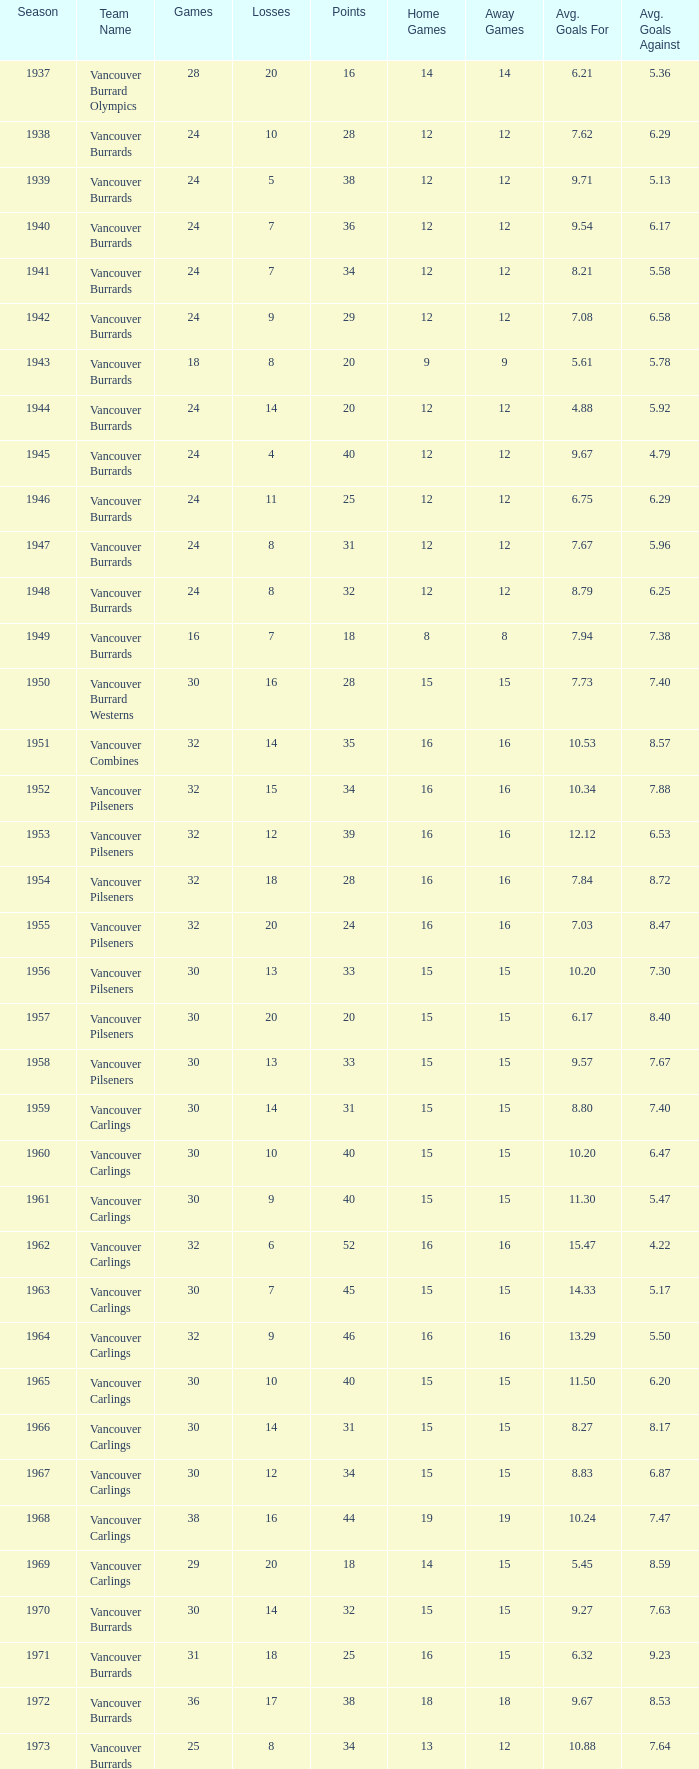What's the total number of points when the vancouver carlings have fewer than 12 losses and more than 32 games? 0.0. 